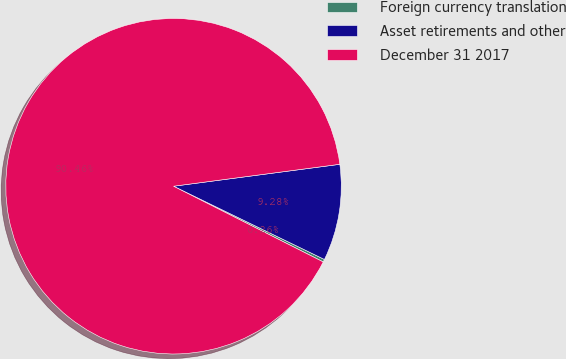Convert chart. <chart><loc_0><loc_0><loc_500><loc_500><pie_chart><fcel>Foreign currency translation<fcel>Asset retirements and other<fcel>December 31 2017<nl><fcel>0.26%<fcel>9.28%<fcel>90.46%<nl></chart> 